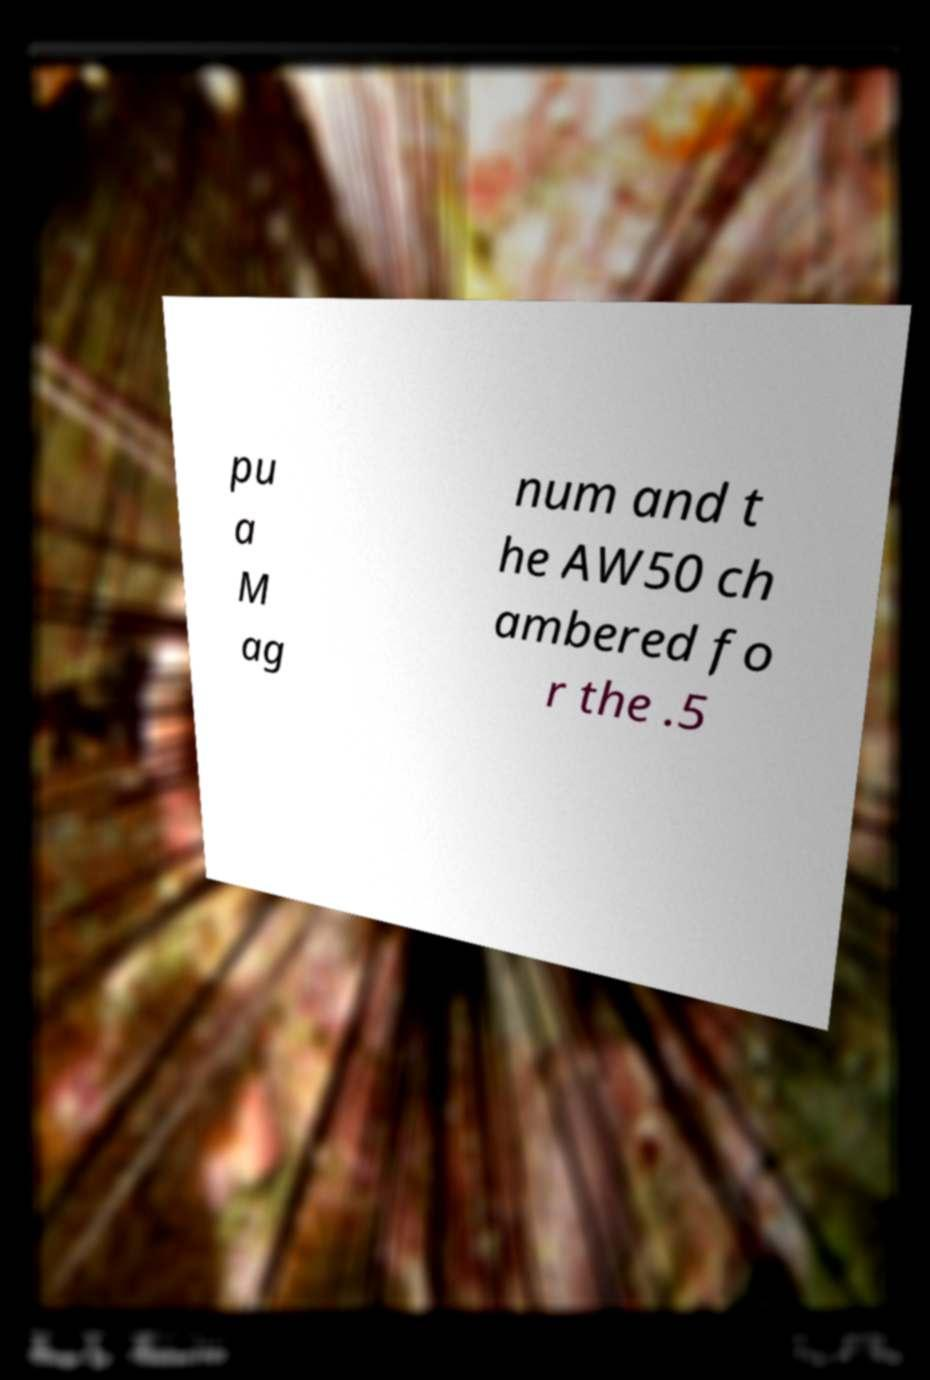Can you read and provide the text displayed in the image?This photo seems to have some interesting text. Can you extract and type it out for me? pu a M ag num and t he AW50 ch ambered fo r the .5 